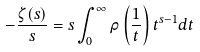Convert formula to latex. <formula><loc_0><loc_0><loc_500><loc_500>- \frac { \zeta ( s ) } { s } = s \int _ { 0 } ^ { \infty } \rho \left ( \frac { 1 } { t } \right ) t ^ { s - 1 } d t</formula> 